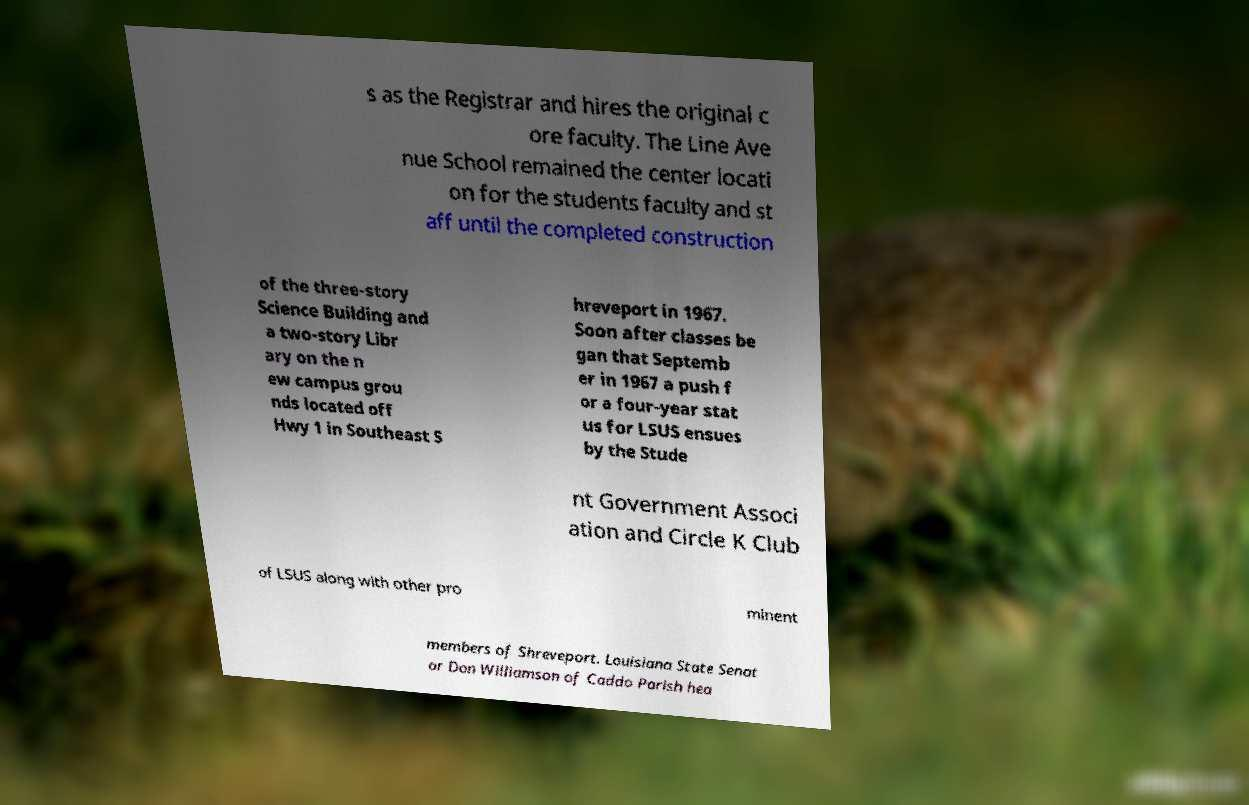What messages or text are displayed in this image? I need them in a readable, typed format. s as the Registrar and hires the original c ore faculty. The Line Ave nue School remained the center locati on for the students faculty and st aff until the completed construction of the three-story Science Building and a two-story Libr ary on the n ew campus grou nds located off Hwy 1 in Southeast S hreveport in 1967. Soon after classes be gan that Septemb er in 1967 a push f or a four-year stat us for LSUS ensues by the Stude nt Government Associ ation and Circle K Club of LSUS along with other pro minent members of Shreveport. Louisiana State Senat or Don Williamson of Caddo Parish hea 